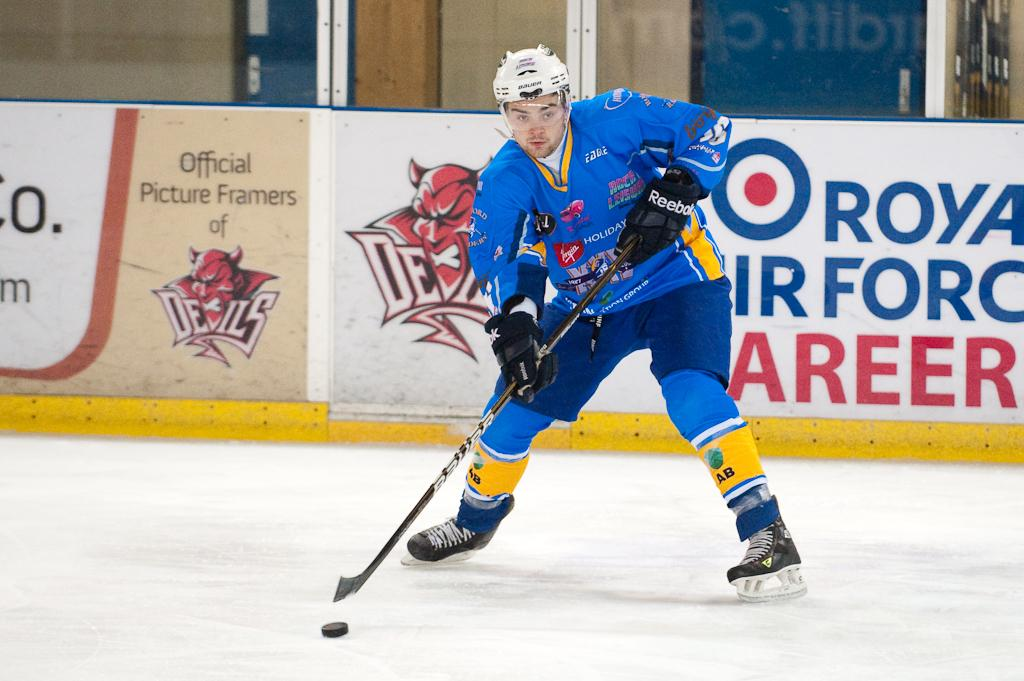<image>
Give a short and clear explanation of the subsequent image. A hockey player is getting ready to shoot the puck, in front of a banner, inside the arena, advertising an Air Force career. 